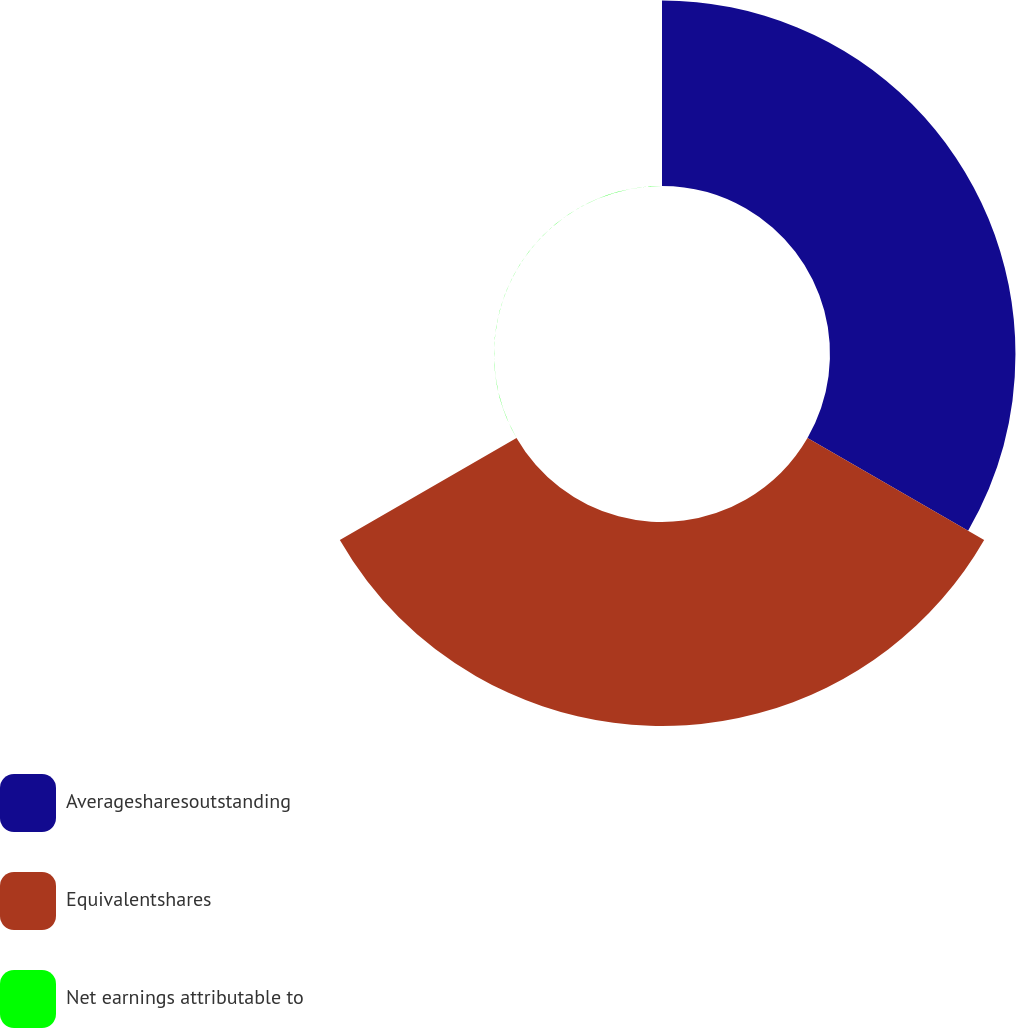Convert chart. <chart><loc_0><loc_0><loc_500><loc_500><pie_chart><fcel>Averagesharesoutstanding<fcel>Equivalentshares<fcel>Net earnings attributable to<nl><fcel>47.62%<fcel>52.38%<fcel>0.0%<nl></chart> 